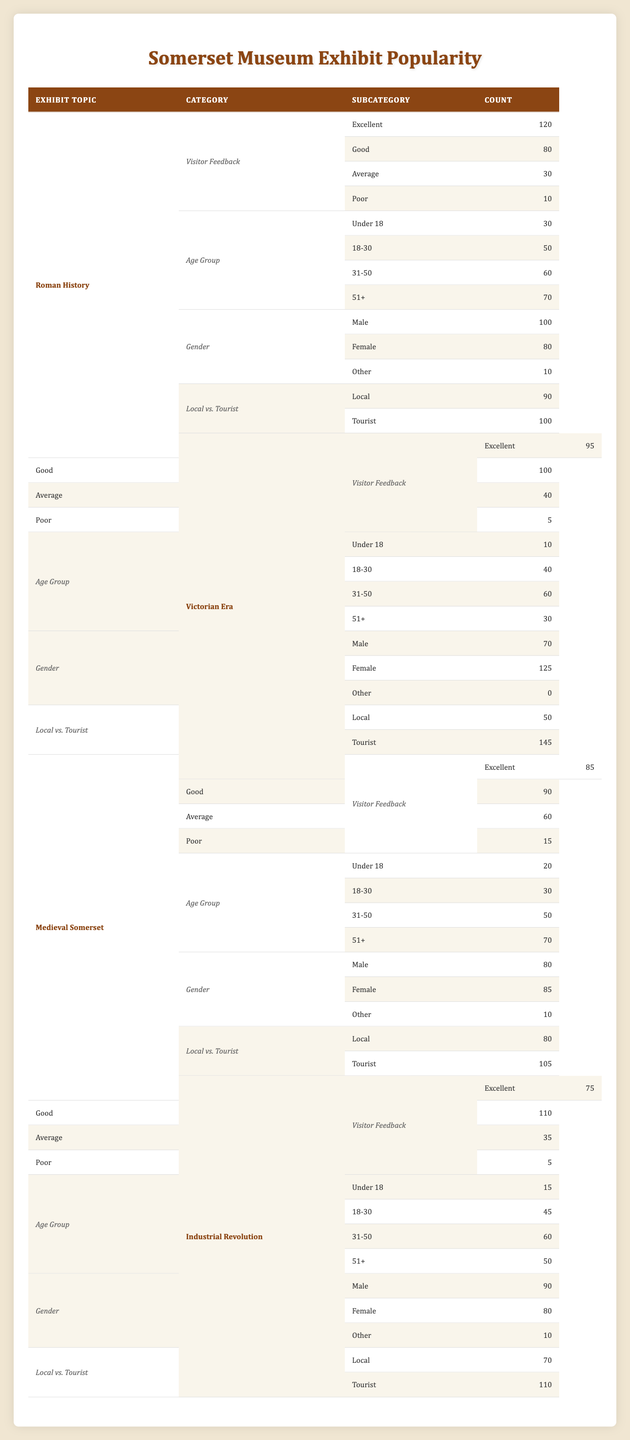What is the total number of visitors who rated the "Industrial Revolution" exhibit as "Excellent"? The "Excellent" rating for the "Industrial Revolution" exhibit is listed in the table as 75. Therefore, the total number of visitors who rated it as "Excellent" is 75.
Answer: 75 Which exhibit topic received the highest number of "Excellent" ratings? Looking through the table, the "Roman History" exhibit received 120 "Excellent" ratings, which is higher than any other exhibit topic's "Excellent" ratings. Thus, "Roman History" received the highest.
Answer: Roman History What is the total feedback count for the "Victorian Era" exhibit from visitors rating it as "Poor"? The count for "Poor" ratings under the "Victorian Era" topic is listed as 5. Thus, the total feedback count for "Poor" ratings for this topic is simply 5.
Answer: 5 Which demographic group liked the "Medieval Somerset" exhibit the most based on "Excellent" feedback? The "Excellent" feedback count for "Medieval Somerset" is 85. We do not have demographic breakdowns for the "Excellent" category in the same way we do for gender or age group, but the highest age group number is 70 for age 51+, indicating that older visitors probably positively viewed the exhibit. However, without specific "Excellent" ratings by age, this question can only be inferential.
Answer: Age group of 51+ What percentage of female visitors rated the "Victorian Era" exhibit as "Good"? The "Good" ratings for the "Victorian Era" exhibit are 100, while female visitors rate it as 125 in total. To find the percentage of female ratings within "Good," we need to calculate (100/125) * 100, which results in 80%.
Answer: 80% True or False: More tourists liked the "Industrial Revolution" exhibit than locals based on the feedback ratings. For the "Industrial Revolution" exhibit, the table shows that 110 tourists viewed it as positive (combining "Excellent" and "Good"), compared to 70 locals. Therefore, it is true that more tourists liked the exhibit.
Answer: True Which exhibit had the highest number of visitors from the "31-50" age group? The numbers from the table indicate that the "Industrial Revolution" and "Victorian Era" exhibits both had 60 visitors in the "31-50" age group, which is the highest compared to others. Thus, there is a tie between these two exhibits.
Answer: Industrial Revolution and Victorian Era What is the total count of feedback ratings if the "Excellent" for "Roman History" is excluded? The total feedback ratings for "Roman History" consists of 120 (Excellent) + 80 (Good) + 30 (Average) + 10 (Poor), which totals to 240. When excluding the "Excellent" ratings (120), the new total is 240 - 120 = 120.
Answer: 120 What is the average "Good" rating count across all four exhibits? The "Good" ratings from each exhibit are as follows: Roman History (80), Victorian Era (100), Medieval Somerset (90), and Industrial Revolution (110). To find the average, we sum these ratings giving us 80 + 100 + 90 + 110 = 380, then divide by 4 to get an average of 95.
Answer: 95 